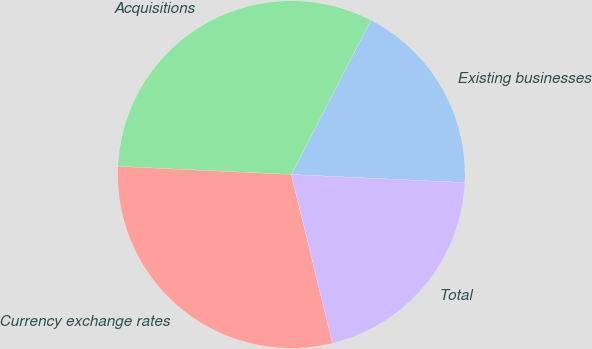Convert chart to OTSL. <chart><loc_0><loc_0><loc_500><loc_500><pie_chart><fcel>Existing businesses<fcel>Acquisitions<fcel>Currency exchange rates<fcel>Total<nl><fcel>18.18%<fcel>31.82%<fcel>29.55%<fcel>20.45%<nl></chart> 